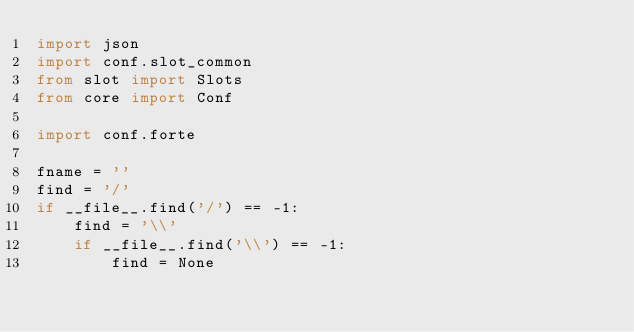Convert code to text. <code><loc_0><loc_0><loc_500><loc_500><_Python_>import json
import conf.slot_common
from slot import Slots
from core import Conf

import conf.forte

fname = ''
find = '/'
if __file__.find('/') == -1:
    find = '\\'
    if __file__.find('\\') == -1:
        find = None</code> 